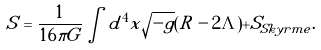<formula> <loc_0><loc_0><loc_500><loc_500>S = \frac { 1 } { 1 6 \pi G } \int d ^ { 4 } x \sqrt { - g } ( R - 2 \Lambda ) + S _ { S k y r m e } .</formula> 